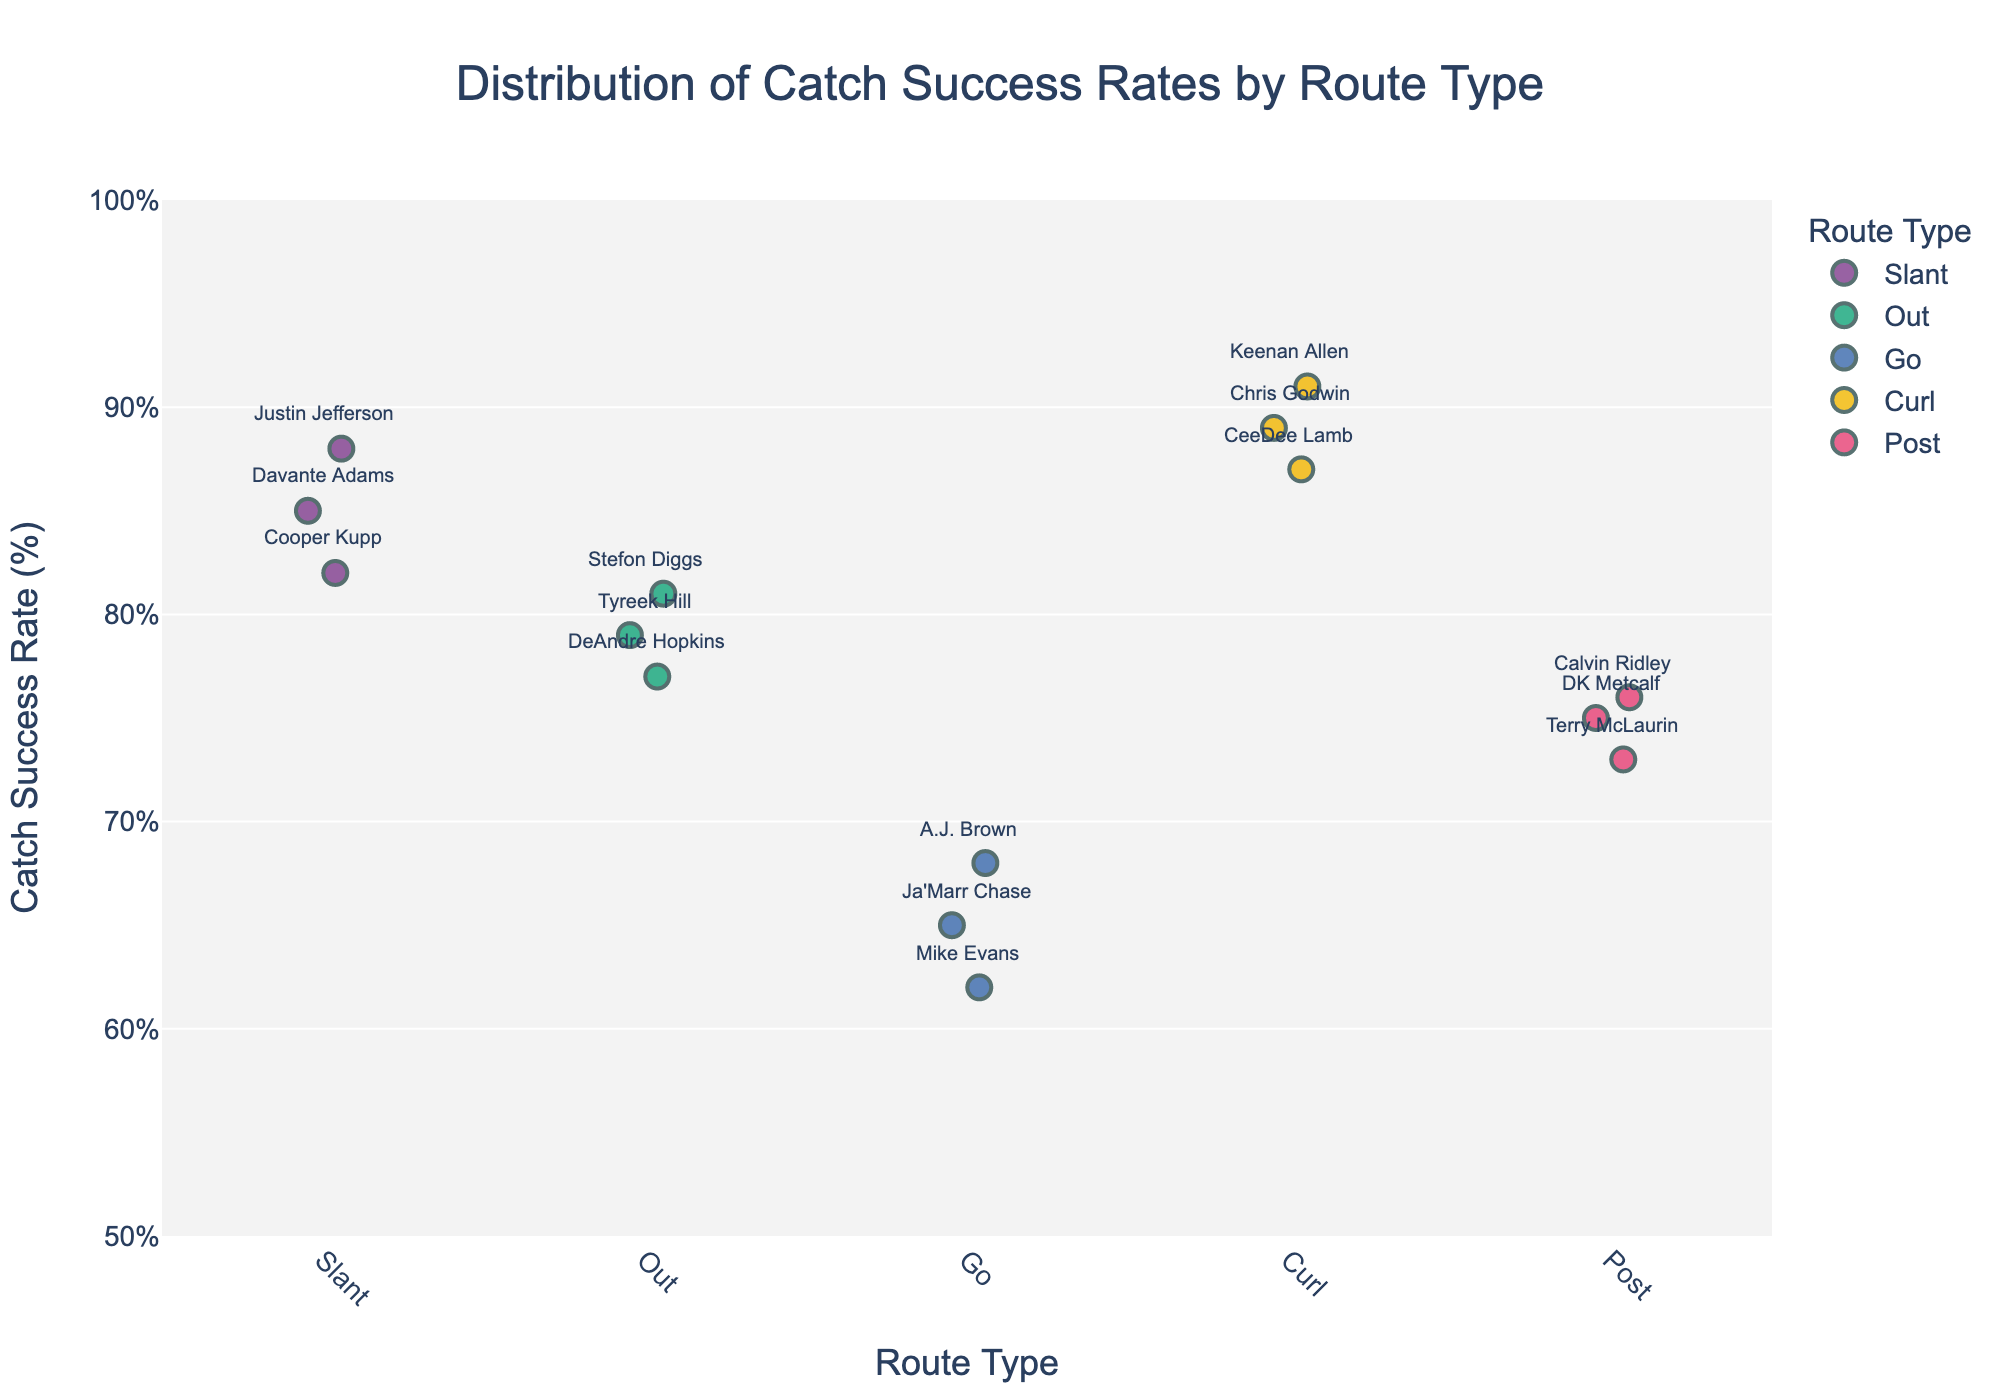What is the title of the figure? The title is typically located at the top of the figure. It summarizes what the figure is about, in this case, it is "Distribution of Catch Success Rates by Route Type."
Answer: Distribution of Catch Success Rates by Route Type Which route type has the highest individual catch success rate? By examining the y-values for each route type, you can compare and see that the highest individual catch success rate is for the "Curl" route type, specifically for Keenan Allen with a rate of 0.91.
Answer: Curl Who has the highest catch success rate on slant routes? Look at the data points corresponding to the slant route type and identify which one has the highest y-value. Justin Jefferson has the highest catch success rate on slant routes.
Answer: Justin Jefferson What is the average catch success rate for out routes? To find the average, locate all data points for the out route type and add their catch success rates (0.79, 0.81, and 0.77), then divide by the number of points (3). (0.79 + 0.81 + 0.77) / 3 = 0.79
Answer: 0.79 How do the success rates for post routes compare to those for go routes? Compare the y-values for post and go routes. The post route success rates (0.76, 0.73, 0.75) generally tend to be higher than those for go routes (0.65, 0.62, 0.68).
Answer: Post routes have higher rates Which player on the figure has the lowest catch success rate, and what route type is it? Look for the data point with the lowest y-value. Mike Evans on the Go route type has the lowest catch success rate of 0.62.
Answer: Mike Evans, Go Are the catch success rates for curl routes generally higher than 0.85? Examine the y-values for all curl routes. All points (0.91, 0.89, 0.87) are above 0.85.
Answer: Yes Among the routes plotted, which one seems to have the most consistent catch success rates? Look for the route type where the y-values are closest to each other, suggesting consistency. Curl routes have success rates clustered closely around 0.89 to 0.91.
Answer: Curl Which route type has the most variability in catch success rates? Identify the route type with the greatest spread in y-values. The Go route type has the most variability with catch success rates ranging from 0.62 to 0.68.
Answer: Go What is the range of catch success rates for slant routes? The range is the difference between the highest and lowest catch success rates for slant routes. For slant routes, the highest rate is 0.88 (Justin Jefferson) and the lowest is 0.82 (Cooper Kupp). So, 0.88 - 0.82 = 0.06.
Answer: 0.06 